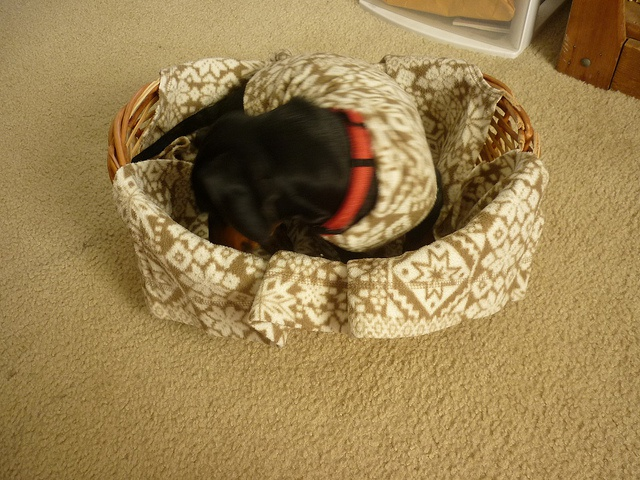Describe the objects in this image and their specific colors. I can see a dog in olive, black, and tan tones in this image. 